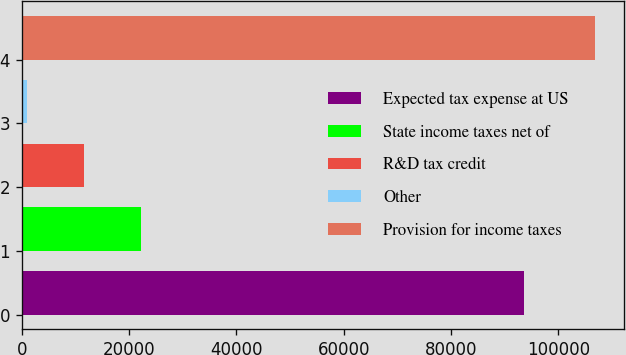<chart> <loc_0><loc_0><loc_500><loc_500><bar_chart><fcel>Expected tax expense at US<fcel>State income taxes net of<fcel>R&D tax credit<fcel>Other<fcel>Provision for income taxes<nl><fcel>93694<fcel>22174.2<fcel>11590.6<fcel>1007<fcel>106843<nl></chart> 